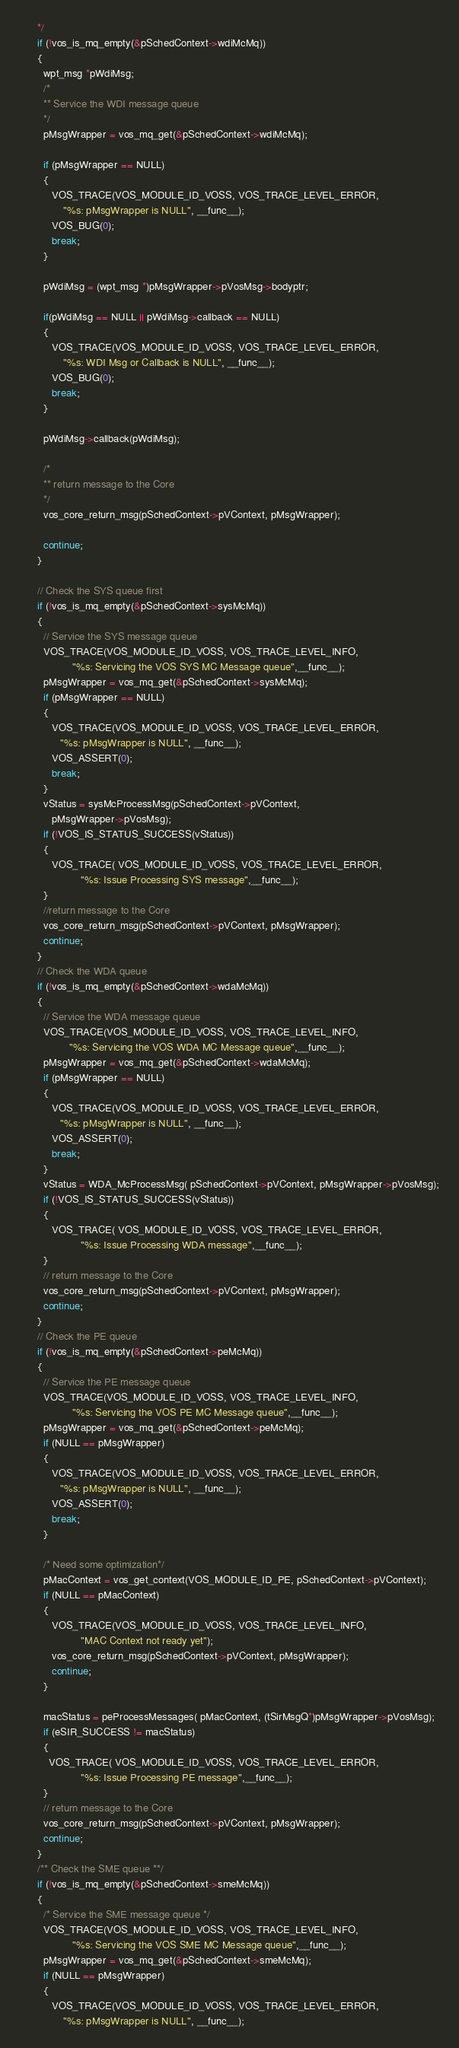Convert code to text. <code><loc_0><loc_0><loc_500><loc_500><_C_>      */
      if (!vos_is_mq_empty(&pSchedContext->wdiMcMq))
      {
        wpt_msg *pWdiMsg;
        /*
        ** Service the WDI message queue
        */
        pMsgWrapper = vos_mq_get(&pSchedContext->wdiMcMq);

        if (pMsgWrapper == NULL)
        {
           VOS_TRACE(VOS_MODULE_ID_VOSS, VOS_TRACE_LEVEL_ERROR,
               "%s: pMsgWrapper is NULL", __func__);
           VOS_BUG(0);
           break;
        }

        pWdiMsg = (wpt_msg *)pMsgWrapper->pVosMsg->bodyptr;

        if(pWdiMsg == NULL || pWdiMsg->callback == NULL)
        {
           VOS_TRACE(VOS_MODULE_ID_VOSS, VOS_TRACE_LEVEL_ERROR,
               "%s: WDI Msg or Callback is NULL", __func__);
           VOS_BUG(0);
           break;
        }

        pWdiMsg->callback(pWdiMsg);

        /* 
        ** return message to the Core
        */
        vos_core_return_msg(pSchedContext->pVContext, pMsgWrapper);

        continue;
      }

      // Check the SYS queue first
      if (!vos_is_mq_empty(&pSchedContext->sysMcMq))
      {
        // Service the SYS message queue
        VOS_TRACE(VOS_MODULE_ID_VOSS, VOS_TRACE_LEVEL_INFO,
                  "%s: Servicing the VOS SYS MC Message queue",__func__);
        pMsgWrapper = vos_mq_get(&pSchedContext->sysMcMq);
        if (pMsgWrapper == NULL)
        {
           VOS_TRACE(VOS_MODULE_ID_VOSS, VOS_TRACE_LEVEL_ERROR,
              "%s: pMsgWrapper is NULL", __func__);
           VOS_ASSERT(0);
           break;
        }
        vStatus = sysMcProcessMsg(pSchedContext->pVContext,
           pMsgWrapper->pVosMsg);
        if (!VOS_IS_STATUS_SUCCESS(vStatus))
        {
           VOS_TRACE( VOS_MODULE_ID_VOSS, VOS_TRACE_LEVEL_ERROR,
                     "%s: Issue Processing SYS message",__func__);
        }
        //return message to the Core
        vos_core_return_msg(pSchedContext->pVContext, pMsgWrapper);
        continue;
      }
      // Check the WDA queue
      if (!vos_is_mq_empty(&pSchedContext->wdaMcMq))
      {
        // Service the WDA message queue
        VOS_TRACE(VOS_MODULE_ID_VOSS, VOS_TRACE_LEVEL_INFO,
                 "%s: Servicing the VOS WDA MC Message queue",__func__);
        pMsgWrapper = vos_mq_get(&pSchedContext->wdaMcMq);
        if (pMsgWrapper == NULL)
        {
           VOS_TRACE(VOS_MODULE_ID_VOSS, VOS_TRACE_LEVEL_ERROR,
              "%s: pMsgWrapper is NULL", __func__);
           VOS_ASSERT(0);
           break;
        }
        vStatus = WDA_McProcessMsg( pSchedContext->pVContext, pMsgWrapper->pVosMsg);
        if (!VOS_IS_STATUS_SUCCESS(vStatus))
        {
           VOS_TRACE( VOS_MODULE_ID_VOSS, VOS_TRACE_LEVEL_ERROR,
                     "%s: Issue Processing WDA message",__func__);
        }
        // return message to the Core
        vos_core_return_msg(pSchedContext->pVContext, pMsgWrapper);
        continue;
      }
      // Check the PE queue
      if (!vos_is_mq_empty(&pSchedContext->peMcMq))
      {
        // Service the PE message queue
        VOS_TRACE(VOS_MODULE_ID_VOSS, VOS_TRACE_LEVEL_INFO,
                  "%s: Servicing the VOS PE MC Message queue",__func__);
        pMsgWrapper = vos_mq_get(&pSchedContext->peMcMq);
        if (NULL == pMsgWrapper)
        {
           VOS_TRACE(VOS_MODULE_ID_VOSS, VOS_TRACE_LEVEL_ERROR,
              "%s: pMsgWrapper is NULL", __func__);
           VOS_ASSERT(0);
           break;
        }

        /* Need some optimization*/
        pMacContext = vos_get_context(VOS_MODULE_ID_PE, pSchedContext->pVContext);
        if (NULL == pMacContext)
        {
           VOS_TRACE(VOS_MODULE_ID_VOSS, VOS_TRACE_LEVEL_INFO,
                     "MAC Context not ready yet");
           vos_core_return_msg(pSchedContext->pVContext, pMsgWrapper);
           continue;
        }

        macStatus = peProcessMessages( pMacContext, (tSirMsgQ*)pMsgWrapper->pVosMsg);
        if (eSIR_SUCCESS != macStatus)
        {
          VOS_TRACE( VOS_MODULE_ID_VOSS, VOS_TRACE_LEVEL_ERROR,
                     "%s: Issue Processing PE message",__func__);
        }
        // return message to the Core
        vos_core_return_msg(pSchedContext->pVContext, pMsgWrapper);
        continue;
      }
      /** Check the SME queue **/
      if (!vos_is_mq_empty(&pSchedContext->smeMcMq))
      {
        /* Service the SME message queue */
        VOS_TRACE(VOS_MODULE_ID_VOSS, VOS_TRACE_LEVEL_INFO,
                  "%s: Servicing the VOS SME MC Message queue",__func__);
        pMsgWrapper = vos_mq_get(&pSchedContext->smeMcMq);
        if (NULL == pMsgWrapper)
        {
           VOS_TRACE(VOS_MODULE_ID_VOSS, VOS_TRACE_LEVEL_ERROR,
               "%s: pMsgWrapper is NULL", __func__);</code> 